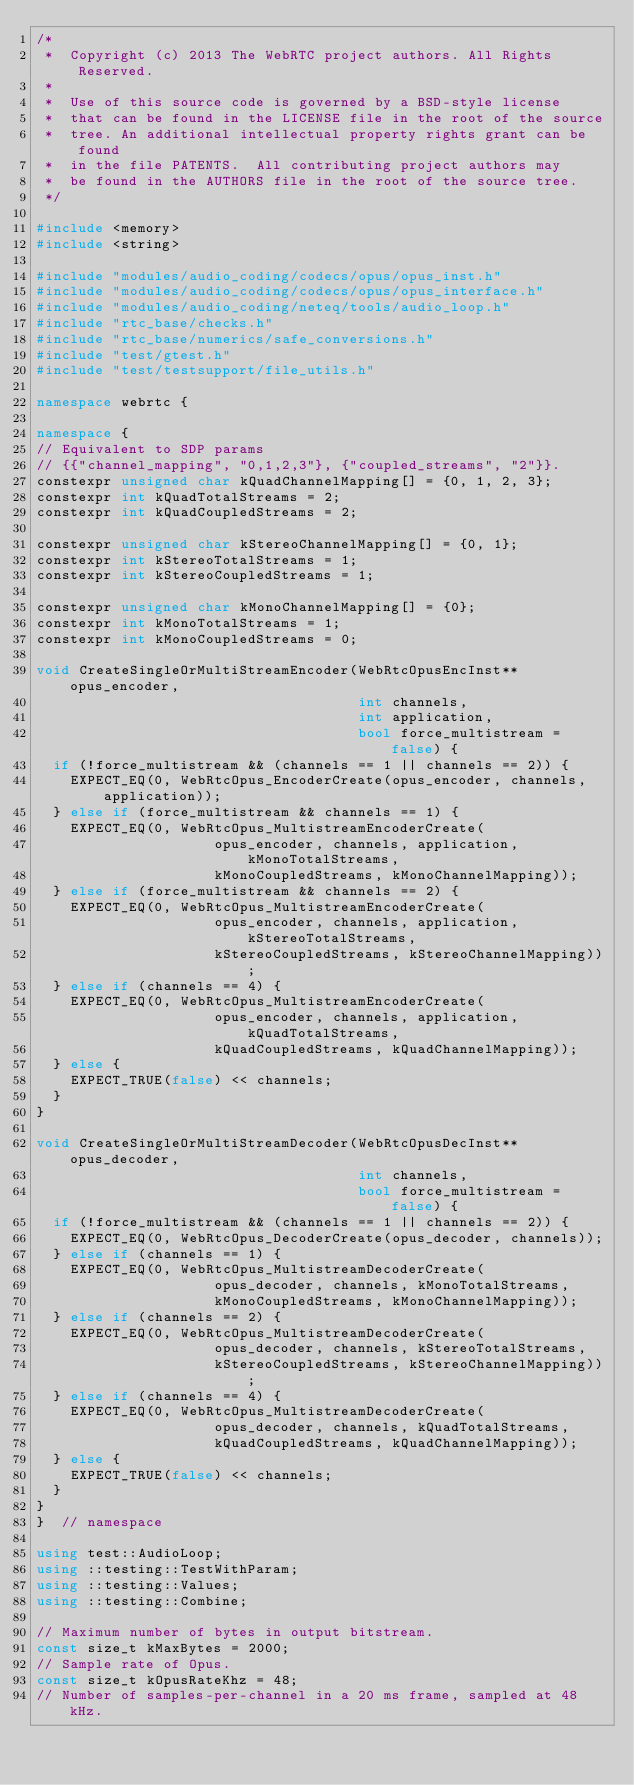Convert code to text. <code><loc_0><loc_0><loc_500><loc_500><_C++_>/*
 *  Copyright (c) 2013 The WebRTC project authors. All Rights Reserved.
 *
 *  Use of this source code is governed by a BSD-style license
 *  that can be found in the LICENSE file in the root of the source
 *  tree. An additional intellectual property rights grant can be found
 *  in the file PATENTS.  All contributing project authors may
 *  be found in the AUTHORS file in the root of the source tree.
 */

#include <memory>
#include <string>

#include "modules/audio_coding/codecs/opus/opus_inst.h"
#include "modules/audio_coding/codecs/opus/opus_interface.h"
#include "modules/audio_coding/neteq/tools/audio_loop.h"
#include "rtc_base/checks.h"
#include "rtc_base/numerics/safe_conversions.h"
#include "test/gtest.h"
#include "test/testsupport/file_utils.h"

namespace webrtc {

namespace {
// Equivalent to SDP params
// {{"channel_mapping", "0,1,2,3"}, {"coupled_streams", "2"}}.
constexpr unsigned char kQuadChannelMapping[] = {0, 1, 2, 3};
constexpr int kQuadTotalStreams = 2;
constexpr int kQuadCoupledStreams = 2;

constexpr unsigned char kStereoChannelMapping[] = {0, 1};
constexpr int kStereoTotalStreams = 1;
constexpr int kStereoCoupledStreams = 1;

constexpr unsigned char kMonoChannelMapping[] = {0};
constexpr int kMonoTotalStreams = 1;
constexpr int kMonoCoupledStreams = 0;

void CreateSingleOrMultiStreamEncoder(WebRtcOpusEncInst** opus_encoder,
                                      int channels,
                                      int application,
                                      bool force_multistream = false) {
  if (!force_multistream && (channels == 1 || channels == 2)) {
    EXPECT_EQ(0, WebRtcOpus_EncoderCreate(opus_encoder, channels, application));
  } else if (force_multistream && channels == 1) {
    EXPECT_EQ(0, WebRtcOpus_MultistreamEncoderCreate(
                     opus_encoder, channels, application, kMonoTotalStreams,
                     kMonoCoupledStreams, kMonoChannelMapping));
  } else if (force_multistream && channels == 2) {
    EXPECT_EQ(0, WebRtcOpus_MultistreamEncoderCreate(
                     opus_encoder, channels, application, kStereoTotalStreams,
                     kStereoCoupledStreams, kStereoChannelMapping));
  } else if (channels == 4) {
    EXPECT_EQ(0, WebRtcOpus_MultistreamEncoderCreate(
                     opus_encoder, channels, application, kQuadTotalStreams,
                     kQuadCoupledStreams, kQuadChannelMapping));
  } else {
    EXPECT_TRUE(false) << channels;
  }
}

void CreateSingleOrMultiStreamDecoder(WebRtcOpusDecInst** opus_decoder,
                                      int channels,
                                      bool force_multistream = false) {
  if (!force_multistream && (channels == 1 || channels == 2)) {
    EXPECT_EQ(0, WebRtcOpus_DecoderCreate(opus_decoder, channels));
  } else if (channels == 1) {
    EXPECT_EQ(0, WebRtcOpus_MultistreamDecoderCreate(
                     opus_decoder, channels, kMonoTotalStreams,
                     kMonoCoupledStreams, kMonoChannelMapping));
  } else if (channels == 2) {
    EXPECT_EQ(0, WebRtcOpus_MultistreamDecoderCreate(
                     opus_decoder, channels, kStereoTotalStreams,
                     kStereoCoupledStreams, kStereoChannelMapping));
  } else if (channels == 4) {
    EXPECT_EQ(0, WebRtcOpus_MultistreamDecoderCreate(
                     opus_decoder, channels, kQuadTotalStreams,
                     kQuadCoupledStreams, kQuadChannelMapping));
  } else {
    EXPECT_TRUE(false) << channels;
  }
}
}  // namespace

using test::AudioLoop;
using ::testing::TestWithParam;
using ::testing::Values;
using ::testing::Combine;

// Maximum number of bytes in output bitstream.
const size_t kMaxBytes = 2000;
// Sample rate of Opus.
const size_t kOpusRateKhz = 48;
// Number of samples-per-channel in a 20 ms frame, sampled at 48 kHz.</code> 